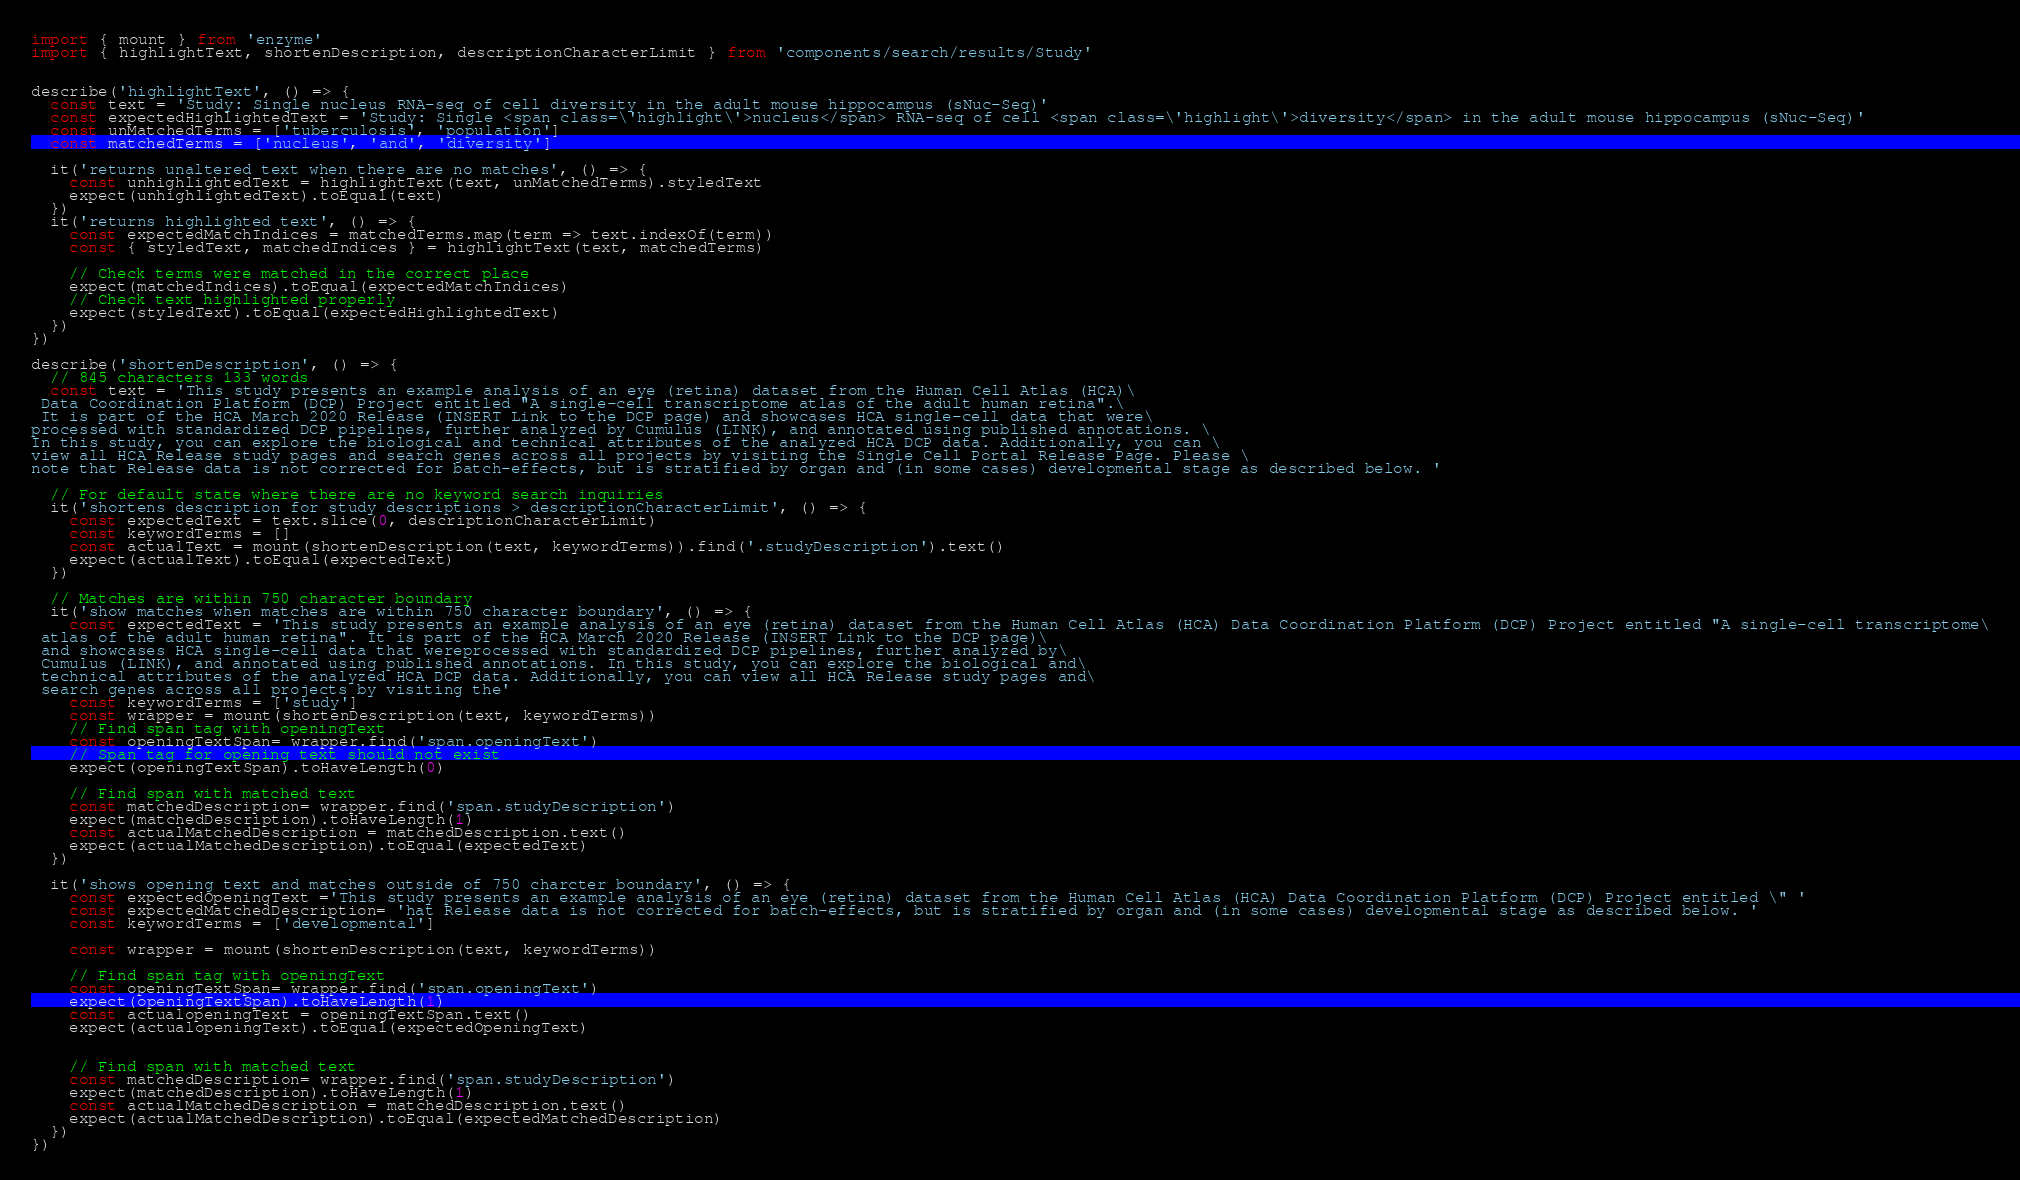<code> <loc_0><loc_0><loc_500><loc_500><_JavaScript_>import { mount } from 'enzyme'
import { highlightText, shortenDescription, descriptionCharacterLimit } from 'components/search/results/Study'


describe('highlightText', () => {
  const text = 'Study: Single nucleus RNA-seq of cell diversity in the adult mouse hippocampus (sNuc-Seq)'
  const expectedHighlightedText = 'Study: Single <span class=\'highlight\'>nucleus</span> RNA-seq of cell <span class=\'highlight\'>diversity</span> in the adult mouse hippocampus (sNuc-Seq)'
  const unMatchedTerms = ['tuberculosis', 'population']
  const matchedTerms = ['nucleus', 'and', 'diversity']

  it('returns unaltered text when there are no matches', () => {
    const unhighlightedText = highlightText(text, unMatchedTerms).styledText
    expect(unhighlightedText).toEqual(text)
  })
  it('returns highlighted text', () => {
    const expectedMatchIndices = matchedTerms.map(term => text.indexOf(term))
    const { styledText, matchedIndices } = highlightText(text, matchedTerms)

    // Check terms were matched in the correct place
    expect(matchedIndices).toEqual(expectedMatchIndices)
    // Check text highlighted properly
    expect(styledText).toEqual(expectedHighlightedText)
  })
})

describe('shortenDescription', () => {
  // 845 characters 133 words
  const text = 'This study presents an example analysis of an eye (retina) dataset from the Human Cell Atlas (HCA)\
 Data Coordination Platform (DCP) Project entitled "A single-cell transcriptome atlas of the adult human retina".\
 It is part of the HCA March 2020 Release (INSERT Link to the DCP page) and showcases HCA single-cell data that were\
processed with standardized DCP pipelines, further analyzed by Cumulus (LINK), and annotated using published annotations. \
In this study, you can explore the biological and technical attributes of the analyzed HCA DCP data. Additionally, you can \
view all HCA Release study pages and search genes across all projects by visiting the Single Cell Portal Release Page. Please \
note that Release data is not corrected for batch-effects, but is stratified by organ and (in some cases) developmental stage as described below. '

  // For default state where there are no keyword search inquiries
  it('shortens description for study descriptions > descriptionCharacterLimit', () => {
    const expectedText = text.slice(0, descriptionCharacterLimit)
    const keywordTerms = []
    const actualText = mount(shortenDescription(text, keywordTerms)).find('.studyDescription').text()
    expect(actualText).toEqual(expectedText)
  })

  // Matches are within 750 character boundary
  it('show matches when matches are within 750 character boundary', () => {
    const expectedText = 'This study presents an example analysis of an eye (retina) dataset from the Human Cell Atlas (HCA) Data Coordination Platform (DCP) Project entitled "A single-cell transcriptome\
 atlas of the adult human retina". It is part of the HCA March 2020 Release (INSERT Link to the DCP page)\
 and showcases HCA single-cell data that wereprocessed with standardized DCP pipelines, further analyzed by\
 Cumulus (LINK), and annotated using published annotations. In this study, you can explore the biological and\
 technical attributes of the analyzed HCA DCP data. Additionally, you can view all HCA Release study pages and\
 search genes across all projects by visiting the'
    const keywordTerms = ['study']
    const wrapper = mount(shortenDescription(text, keywordTerms))
    // Find span tag with openingText
    const openingTextSpan= wrapper.find('span.openingText')
    // Span tag for opening text should not exist
    expect(openingTextSpan).toHaveLength(0)

    // Find span with matched text
    const matchedDescription= wrapper.find('span.studyDescription')
    expect(matchedDescription).toHaveLength(1)
    const actualMatchedDescription = matchedDescription.text()
    expect(actualMatchedDescription).toEqual(expectedText)
  })

  it('shows opening text and matches outside of 750 charcter boundary', () => {
    const expectedOpeningText ='This study presents an example analysis of an eye (retina) dataset from the Human Cell Atlas (HCA) Data Coordination Platform (DCP) Project entitled \" '
    const expectedMatchedDescription= 'hat Release data is not corrected for batch-effects, but is stratified by organ and (in some cases) developmental stage as described below. '
    const keywordTerms = ['developmental']

    const wrapper = mount(shortenDescription(text, keywordTerms))

    // Find span tag with openingText
    const openingTextSpan= wrapper.find('span.openingText')
    expect(openingTextSpan).toHaveLength(1)
    const actualopeningText = openingTextSpan.text()
    expect(actualopeningText).toEqual(expectedOpeningText)


    // Find span with matched text
    const matchedDescription= wrapper.find('span.studyDescription')
    expect(matchedDescription).toHaveLength(1)
    const actualMatchedDescription = matchedDescription.text()
    expect(actualMatchedDescription).toEqual(expectedMatchedDescription)
  })
})
</code> 